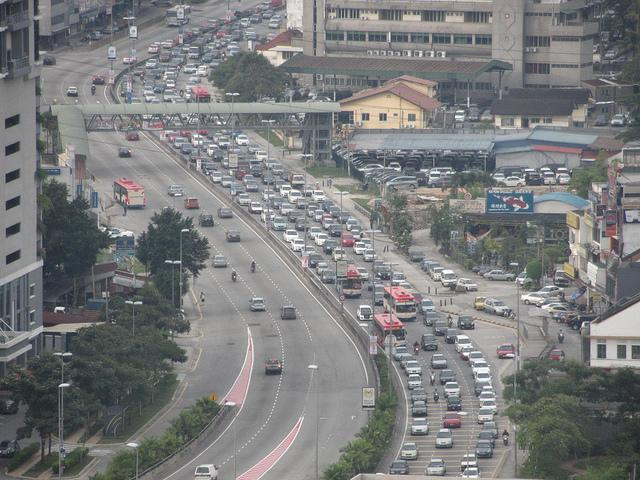What time is it likely to be? rush hour 